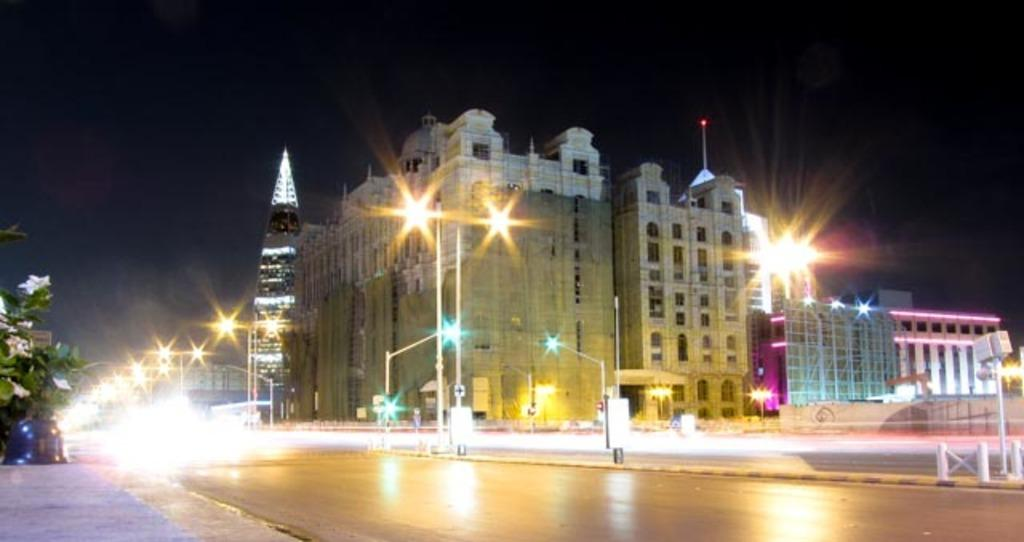What can be seen in the background of the image? There is a big building behind the road in the image. What type of lighting is present along the road? There are street lights visible in the image. Can you describe the vegetation on the left side of the road? There is a small tree on the left side of the road. How many street lights are visible on the road? There are many street lights on the road. What type of crown is placed on the gate in the image? There is no crown or gate present in the image. What type of line is visible on the road in the image? There is no line visible on the road in the image. 